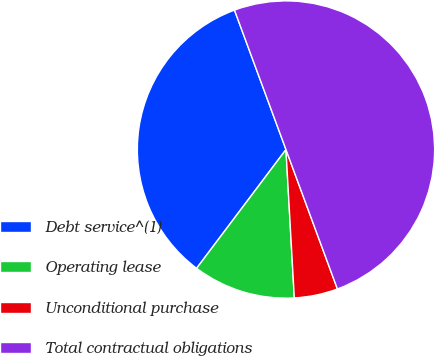Convert chart. <chart><loc_0><loc_0><loc_500><loc_500><pie_chart><fcel>Debt service^(1)<fcel>Operating lease<fcel>Unconditional purchase<fcel>Total contractual obligations<nl><fcel>34.1%<fcel>11.16%<fcel>4.73%<fcel>50.0%<nl></chart> 